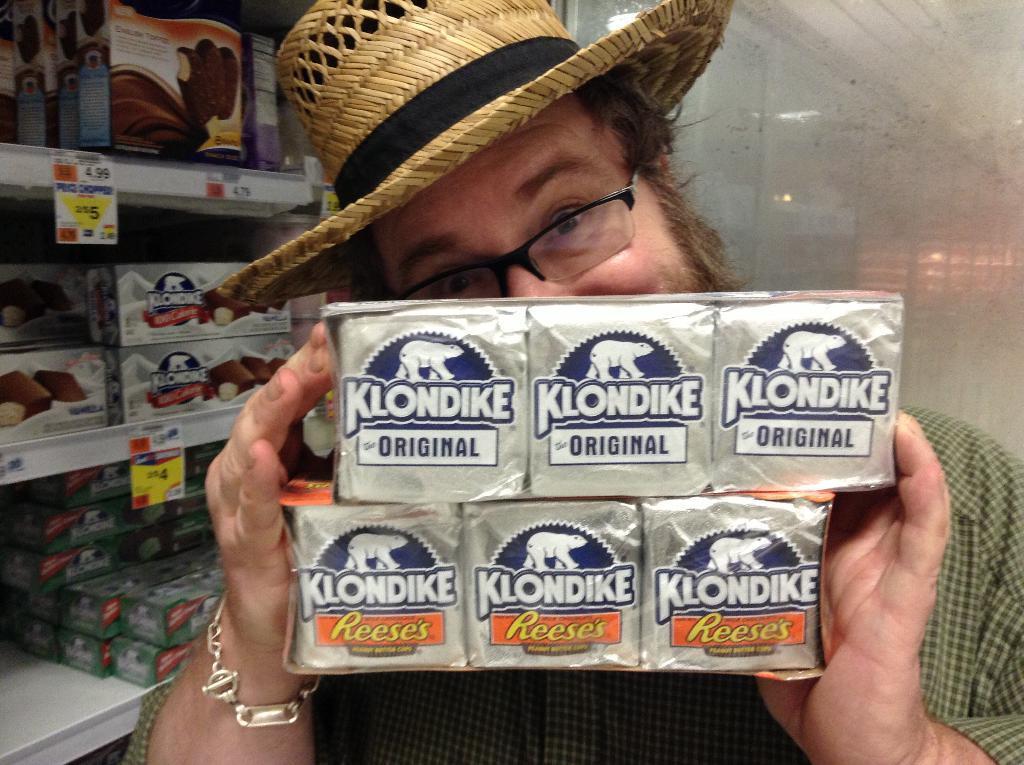Please provide a concise description of this image. In this image there is a man with hat holding someone blocks behind him there is a cupboard with so many things. 